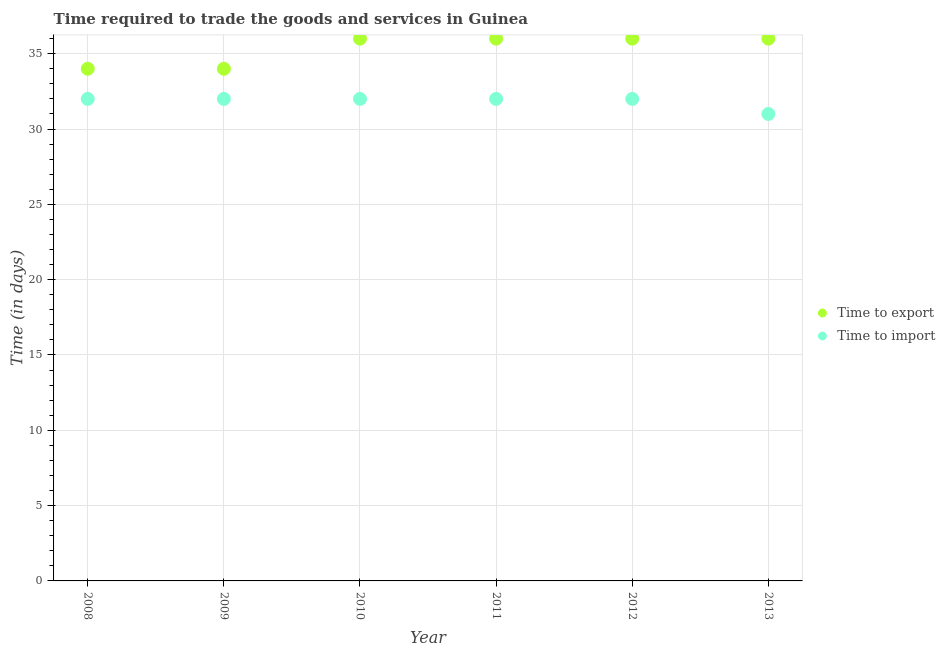What is the time to export in 2012?
Provide a short and direct response. 36. Across all years, what is the maximum time to export?
Offer a very short reply. 36. Across all years, what is the minimum time to import?
Your answer should be compact. 31. In which year was the time to import minimum?
Your response must be concise. 2013. What is the total time to export in the graph?
Ensure brevity in your answer.  212. What is the difference between the time to import in 2013 and the time to export in 2012?
Give a very brief answer. -5. What is the average time to import per year?
Offer a terse response. 31.83. In the year 2008, what is the difference between the time to export and time to import?
Make the answer very short. 2. What is the ratio of the time to export in 2008 to that in 2012?
Your response must be concise. 0.94. What is the difference between the highest and the second highest time to import?
Give a very brief answer. 0. What is the difference between the highest and the lowest time to import?
Provide a short and direct response. 1. In how many years, is the time to export greater than the average time to export taken over all years?
Ensure brevity in your answer.  4. Is the sum of the time to import in 2008 and 2011 greater than the maximum time to export across all years?
Keep it short and to the point. Yes. Is the time to export strictly greater than the time to import over the years?
Offer a very short reply. Yes. How many dotlines are there?
Provide a succinct answer. 2. How many years are there in the graph?
Provide a succinct answer. 6. What is the difference between two consecutive major ticks on the Y-axis?
Make the answer very short. 5. Does the graph contain grids?
Your response must be concise. Yes. How are the legend labels stacked?
Make the answer very short. Vertical. What is the title of the graph?
Provide a succinct answer. Time required to trade the goods and services in Guinea. What is the label or title of the Y-axis?
Your answer should be compact. Time (in days). What is the Time (in days) of Time to export in 2008?
Make the answer very short. 34. What is the Time (in days) in Time to export in 2010?
Keep it short and to the point. 36. What is the Time (in days) in Time to import in 2010?
Provide a succinct answer. 32. What is the Time (in days) in Time to import in 2011?
Offer a terse response. 32. What is the Time (in days) of Time to import in 2012?
Offer a terse response. 32. What is the Time (in days) in Time to export in 2013?
Ensure brevity in your answer.  36. What is the Time (in days) of Time to import in 2013?
Your answer should be very brief. 31. Across all years, what is the maximum Time (in days) in Time to import?
Your answer should be very brief. 32. Across all years, what is the minimum Time (in days) in Time to import?
Provide a short and direct response. 31. What is the total Time (in days) in Time to export in the graph?
Your response must be concise. 212. What is the total Time (in days) in Time to import in the graph?
Your response must be concise. 191. What is the difference between the Time (in days) in Time to import in 2008 and that in 2009?
Offer a very short reply. 0. What is the difference between the Time (in days) of Time to export in 2008 and that in 2011?
Keep it short and to the point. -2. What is the difference between the Time (in days) in Time to export in 2008 and that in 2012?
Your answer should be very brief. -2. What is the difference between the Time (in days) in Time to import in 2008 and that in 2012?
Your answer should be compact. 0. What is the difference between the Time (in days) in Time to export in 2008 and that in 2013?
Give a very brief answer. -2. What is the difference between the Time (in days) of Time to import in 2009 and that in 2010?
Offer a terse response. 0. What is the difference between the Time (in days) in Time to export in 2009 and that in 2011?
Keep it short and to the point. -2. What is the difference between the Time (in days) of Time to import in 2009 and that in 2012?
Provide a short and direct response. 0. What is the difference between the Time (in days) of Time to export in 2009 and that in 2013?
Keep it short and to the point. -2. What is the difference between the Time (in days) in Time to import in 2009 and that in 2013?
Your answer should be very brief. 1. What is the difference between the Time (in days) of Time to import in 2010 and that in 2012?
Provide a succinct answer. 0. What is the difference between the Time (in days) in Time to export in 2010 and that in 2013?
Your answer should be very brief. 0. What is the difference between the Time (in days) in Time to import in 2010 and that in 2013?
Provide a succinct answer. 1. What is the difference between the Time (in days) in Time to export in 2011 and that in 2012?
Give a very brief answer. 0. What is the difference between the Time (in days) in Time to export in 2011 and that in 2013?
Make the answer very short. 0. What is the difference between the Time (in days) in Time to export in 2012 and that in 2013?
Give a very brief answer. 0. What is the difference between the Time (in days) in Time to export in 2008 and the Time (in days) in Time to import in 2011?
Your answer should be compact. 2. What is the difference between the Time (in days) of Time to export in 2008 and the Time (in days) of Time to import in 2012?
Give a very brief answer. 2. What is the difference between the Time (in days) in Time to export in 2009 and the Time (in days) in Time to import in 2010?
Offer a terse response. 2. What is the difference between the Time (in days) of Time to export in 2009 and the Time (in days) of Time to import in 2013?
Your answer should be compact. 3. What is the difference between the Time (in days) of Time to export in 2010 and the Time (in days) of Time to import in 2012?
Your answer should be very brief. 4. What is the difference between the Time (in days) in Time to export in 2011 and the Time (in days) in Time to import in 2012?
Make the answer very short. 4. What is the difference between the Time (in days) in Time to export in 2011 and the Time (in days) in Time to import in 2013?
Provide a short and direct response. 5. What is the average Time (in days) of Time to export per year?
Keep it short and to the point. 35.33. What is the average Time (in days) in Time to import per year?
Ensure brevity in your answer.  31.83. In the year 2008, what is the difference between the Time (in days) in Time to export and Time (in days) in Time to import?
Make the answer very short. 2. In the year 2009, what is the difference between the Time (in days) of Time to export and Time (in days) of Time to import?
Your answer should be compact. 2. In the year 2010, what is the difference between the Time (in days) in Time to export and Time (in days) in Time to import?
Your answer should be very brief. 4. In the year 2011, what is the difference between the Time (in days) of Time to export and Time (in days) of Time to import?
Provide a short and direct response. 4. In the year 2012, what is the difference between the Time (in days) of Time to export and Time (in days) of Time to import?
Your response must be concise. 4. What is the ratio of the Time (in days) in Time to import in 2008 to that in 2009?
Your answer should be compact. 1. What is the ratio of the Time (in days) in Time to export in 2008 to that in 2010?
Your response must be concise. 0.94. What is the ratio of the Time (in days) of Time to import in 2008 to that in 2011?
Your answer should be very brief. 1. What is the ratio of the Time (in days) of Time to export in 2008 to that in 2012?
Provide a short and direct response. 0.94. What is the ratio of the Time (in days) in Time to import in 2008 to that in 2013?
Provide a short and direct response. 1.03. What is the ratio of the Time (in days) of Time to export in 2009 to that in 2010?
Ensure brevity in your answer.  0.94. What is the ratio of the Time (in days) in Time to export in 2009 to that in 2011?
Keep it short and to the point. 0.94. What is the ratio of the Time (in days) of Time to import in 2009 to that in 2012?
Give a very brief answer. 1. What is the ratio of the Time (in days) of Time to import in 2009 to that in 2013?
Keep it short and to the point. 1.03. What is the ratio of the Time (in days) in Time to export in 2010 to that in 2011?
Your answer should be very brief. 1. What is the ratio of the Time (in days) of Time to export in 2010 to that in 2012?
Provide a succinct answer. 1. What is the ratio of the Time (in days) of Time to import in 2010 to that in 2013?
Provide a succinct answer. 1.03. What is the ratio of the Time (in days) of Time to import in 2011 to that in 2012?
Your answer should be compact. 1. What is the ratio of the Time (in days) of Time to import in 2011 to that in 2013?
Ensure brevity in your answer.  1.03. What is the ratio of the Time (in days) in Time to import in 2012 to that in 2013?
Keep it short and to the point. 1.03. What is the difference between the highest and the second highest Time (in days) in Time to import?
Give a very brief answer. 0. What is the difference between the highest and the lowest Time (in days) in Time to export?
Provide a succinct answer. 2. What is the difference between the highest and the lowest Time (in days) in Time to import?
Provide a succinct answer. 1. 